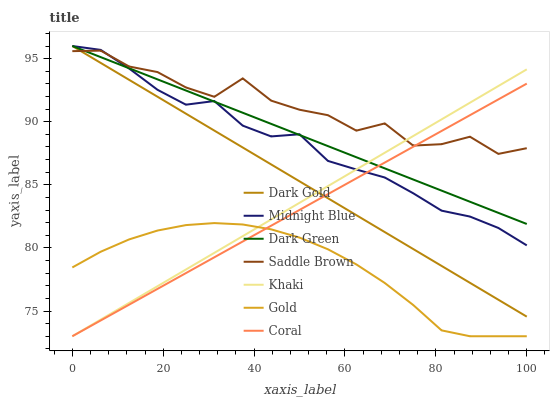Does Gold have the minimum area under the curve?
Answer yes or no. Yes. Does Saddle Brown have the maximum area under the curve?
Answer yes or no. Yes. Does Midnight Blue have the minimum area under the curve?
Answer yes or no. No. Does Midnight Blue have the maximum area under the curve?
Answer yes or no. No. Is Khaki the smoothest?
Answer yes or no. Yes. Is Saddle Brown the roughest?
Answer yes or no. Yes. Is Midnight Blue the smoothest?
Answer yes or no. No. Is Midnight Blue the roughest?
Answer yes or no. No. Does Midnight Blue have the lowest value?
Answer yes or no. No. Does Dark Green have the highest value?
Answer yes or no. Yes. Does Gold have the highest value?
Answer yes or no. No. Is Gold less than Dark Green?
Answer yes or no. Yes. Is Dark Green greater than Gold?
Answer yes or no. Yes. Does Khaki intersect Coral?
Answer yes or no. Yes. Is Khaki less than Coral?
Answer yes or no. No. Is Khaki greater than Coral?
Answer yes or no. No. Does Gold intersect Dark Green?
Answer yes or no. No. 